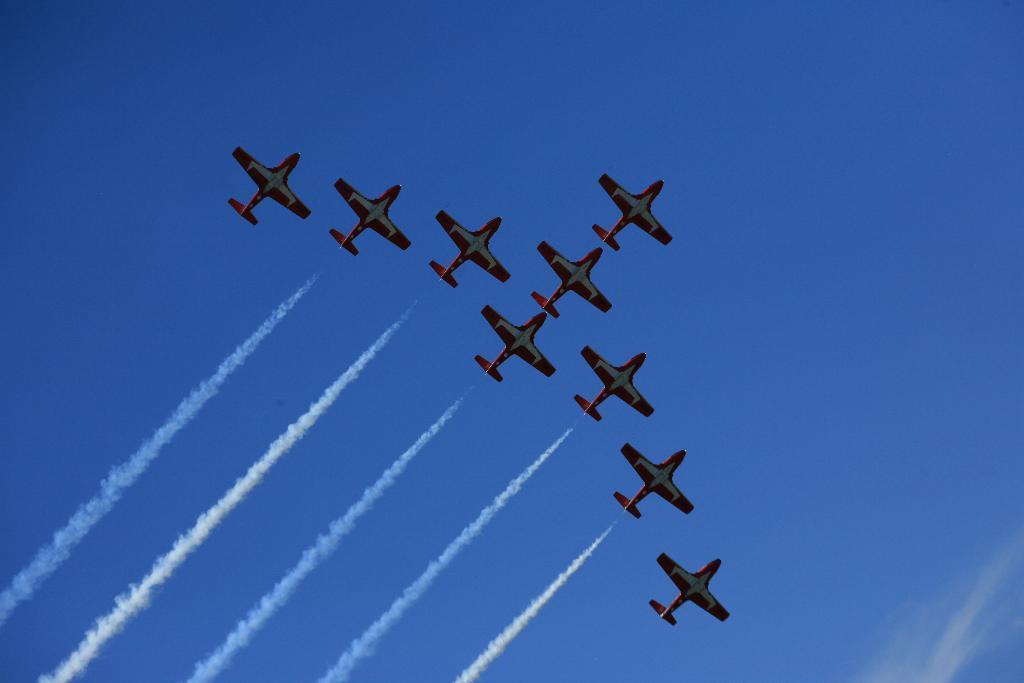How would you summarize this image in a sentence or two? In this image we can see some airplanes in the air. In the background sky is visible. 